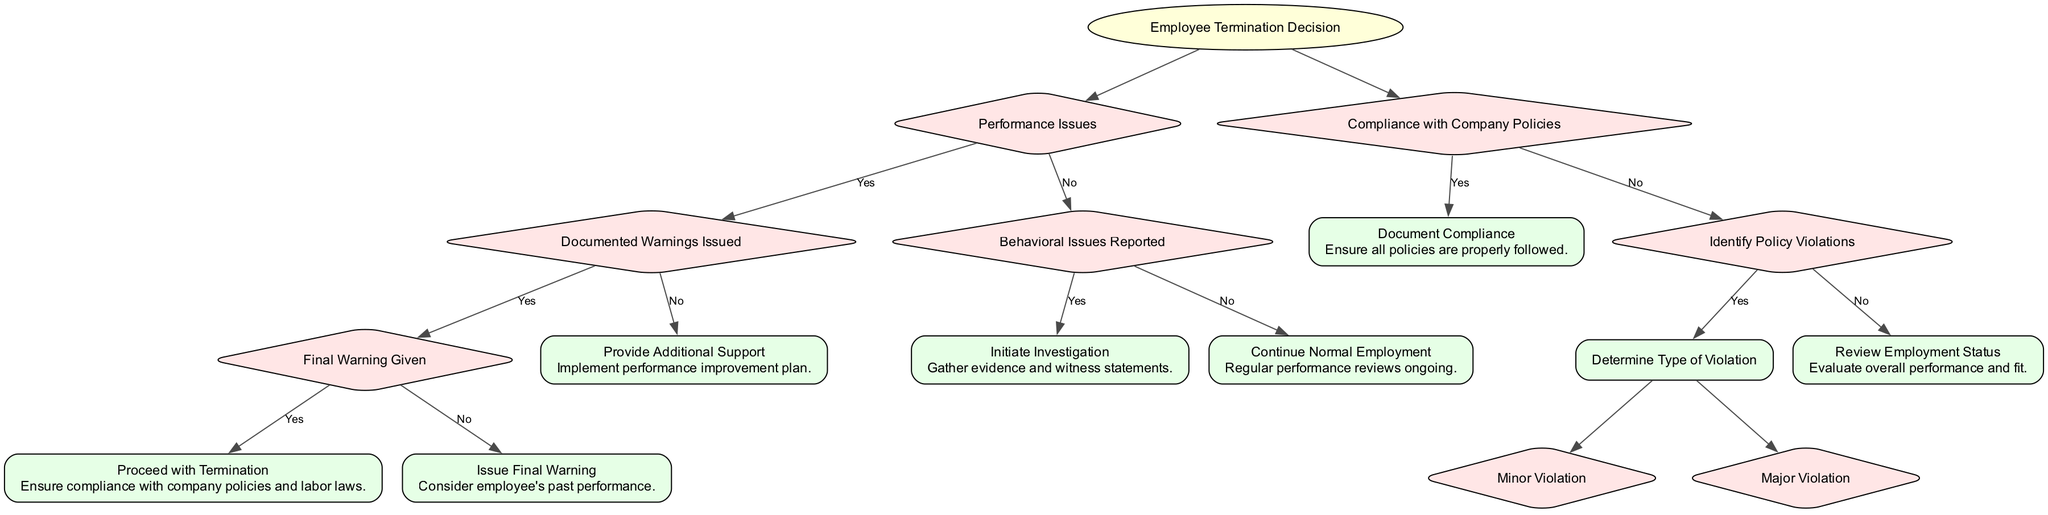What is the root node of the decision tree? The root node is labeled "Employee Termination Decision," which signifies the primary focus of the decision-making process.
Answer: Employee Termination Decision How many branches are there under the root node? The root node has two main branches: one for "Performance Issues" and another for "Compliance with Company Policies." Therefore, there are a total of two branches.
Answer: 2 What outcome occurs if documented warnings are issued and a final warning is given? If a final warning is given after documented warnings, the outcome is "Proceed with Termination," as per the decision path outlined in the diagram.
Answer: Proceed with Termination What action is taken if there are performance issues but no warnings issued? The decision tree indicates that if there are performance issues with no documented warnings, the action is to "Provide Additional Support." This approach focuses on helping the employee improve performance before considering termination.
Answer: Provide Additional Support What happens if there is a major violation identified regarding company policies? If a major violation is verified, the decision tree states that the appropriate action is to "Consider Immediate Termination," which involves consulting with HR and legal counsel to ensure the action is justified and compliant with legal standards.
Answer: Consider Immediate Termination How does the outcome change when there are behavioral issues reported? When behavioral issues are reported, the path leads to "Initiate Investigation," focusing on gathering evidence and statements, which indicates a serious approach to addressing the reported issues before taking further actions.
Answer: Initiate Investigation What is the outcome if compliance with company policies is confirmed? If compliance with company policies is confirmed, the decision tree specifies the outcome as "Document Compliance," indicating that it is essential to keep records of policy adherence.
Answer: Document Compliance What is indicated if there are no performance issues and no behavioral issues reported? The diagram indicates that if there are no performance issues and no behavioral issues reported, the appropriate outcome is to "Continue Normal Employment," suggesting that the employee meets expected performance standards currently.
Answer: Continue Normal Employment What is the outcome of determining a minor violation? When a minor violation is identified, the decision tree states that the outcome is to "Issue Written Warning," serving as documentation of the incident for potential future reference and corrective action.
Answer: Issue Written Warning 